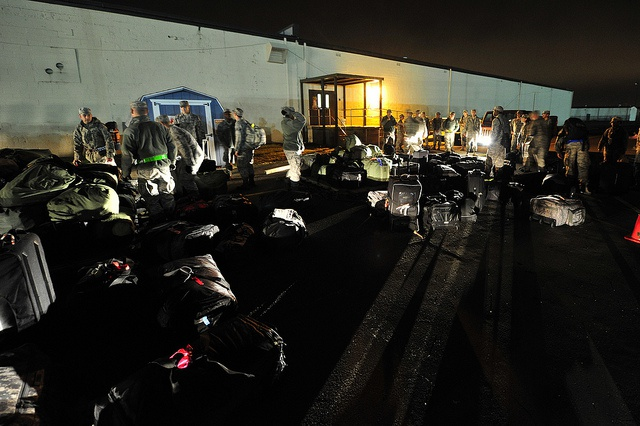Describe the objects in this image and their specific colors. I can see people in gray, black, and maroon tones, suitcase in gray, black, ivory, and darkgray tones, people in gray, black, ivory, and darkgreen tones, suitcase in gray, black, and darkgray tones, and suitcase in gray and black tones in this image. 